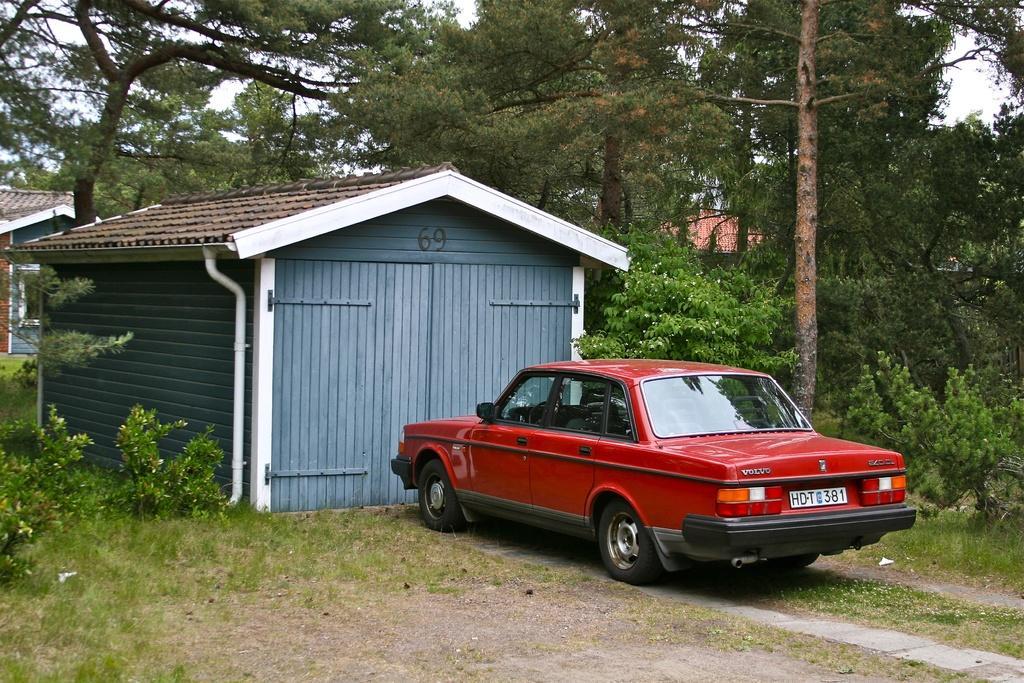In one or two sentences, can you explain what this image depicts? In this image, we can see a few houses. We can see a red colored car. We can the ground. We can see some grass, plants. There are a few trees. We can see the sky. 